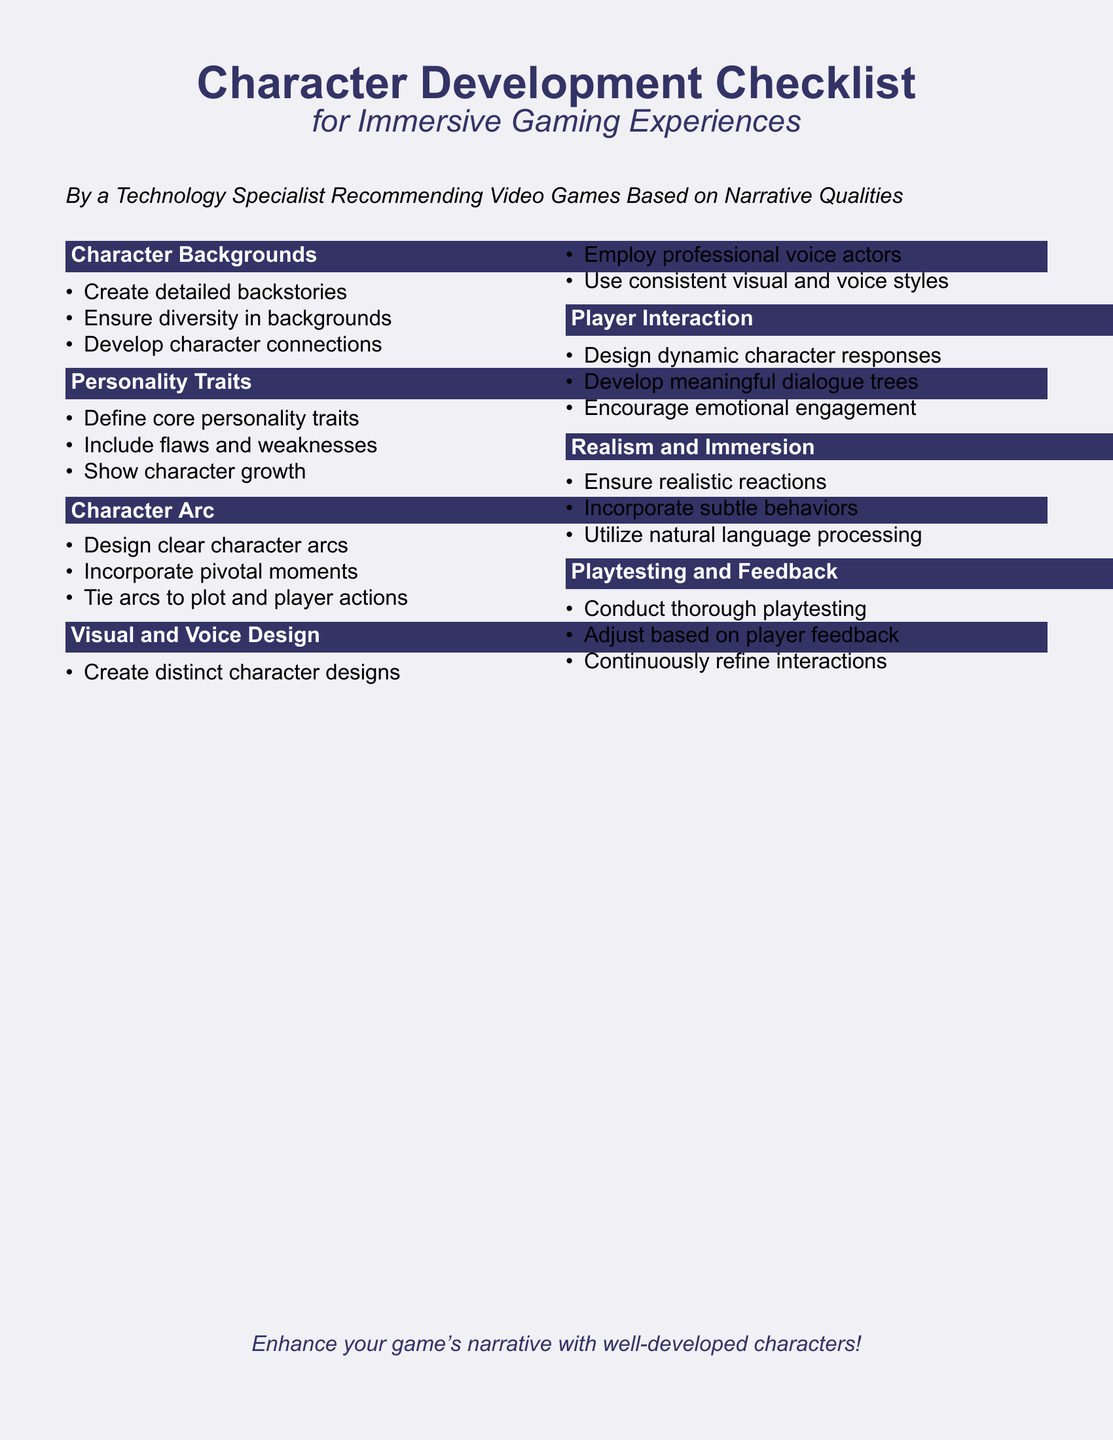What are the key areas of character development? The document contains sections on Character Backgrounds, Personality Traits, Character Arc, Visual and Voice Design, Player Interaction, Realism and Immersion, and Playtesting and Feedback.
Answer: Character Backgrounds, Personality Traits, Character Arc, Visual and Voice Design, Player Interaction, Realism and Immersion, Playtesting and Feedback How many items are listed under Personality Traits? There are three items listed under Personality Traits in the checklist.
Answer: Three What should be designed to encourage emotional engagement? The checklist mentions developing meaningful dialogue trees to encourage emotional engagement.
Answer: Meaningful dialogue trees What is essential for character arcs according to the document? The document states that designing clear character arcs is essential for character development.
Answer: Clear character arcs What technique is suggested for creating character responses? The document suggests designing dynamic character responses for better player interaction.
Answer: Dynamic character responses Who is the author of the checklist? The author of the checklist is a Technology Specialist recommending video games based on narrative qualities.
Answer: A Technology Specialist What should be employed for voice design? The document emphasizes the use of professional voice actors for voice design.
Answer: Professional voice actors What aspect of playtesting is highlighted? The document highlights the importance of conducting thorough playtesting.
Answer: Conduct thorough playtesting 